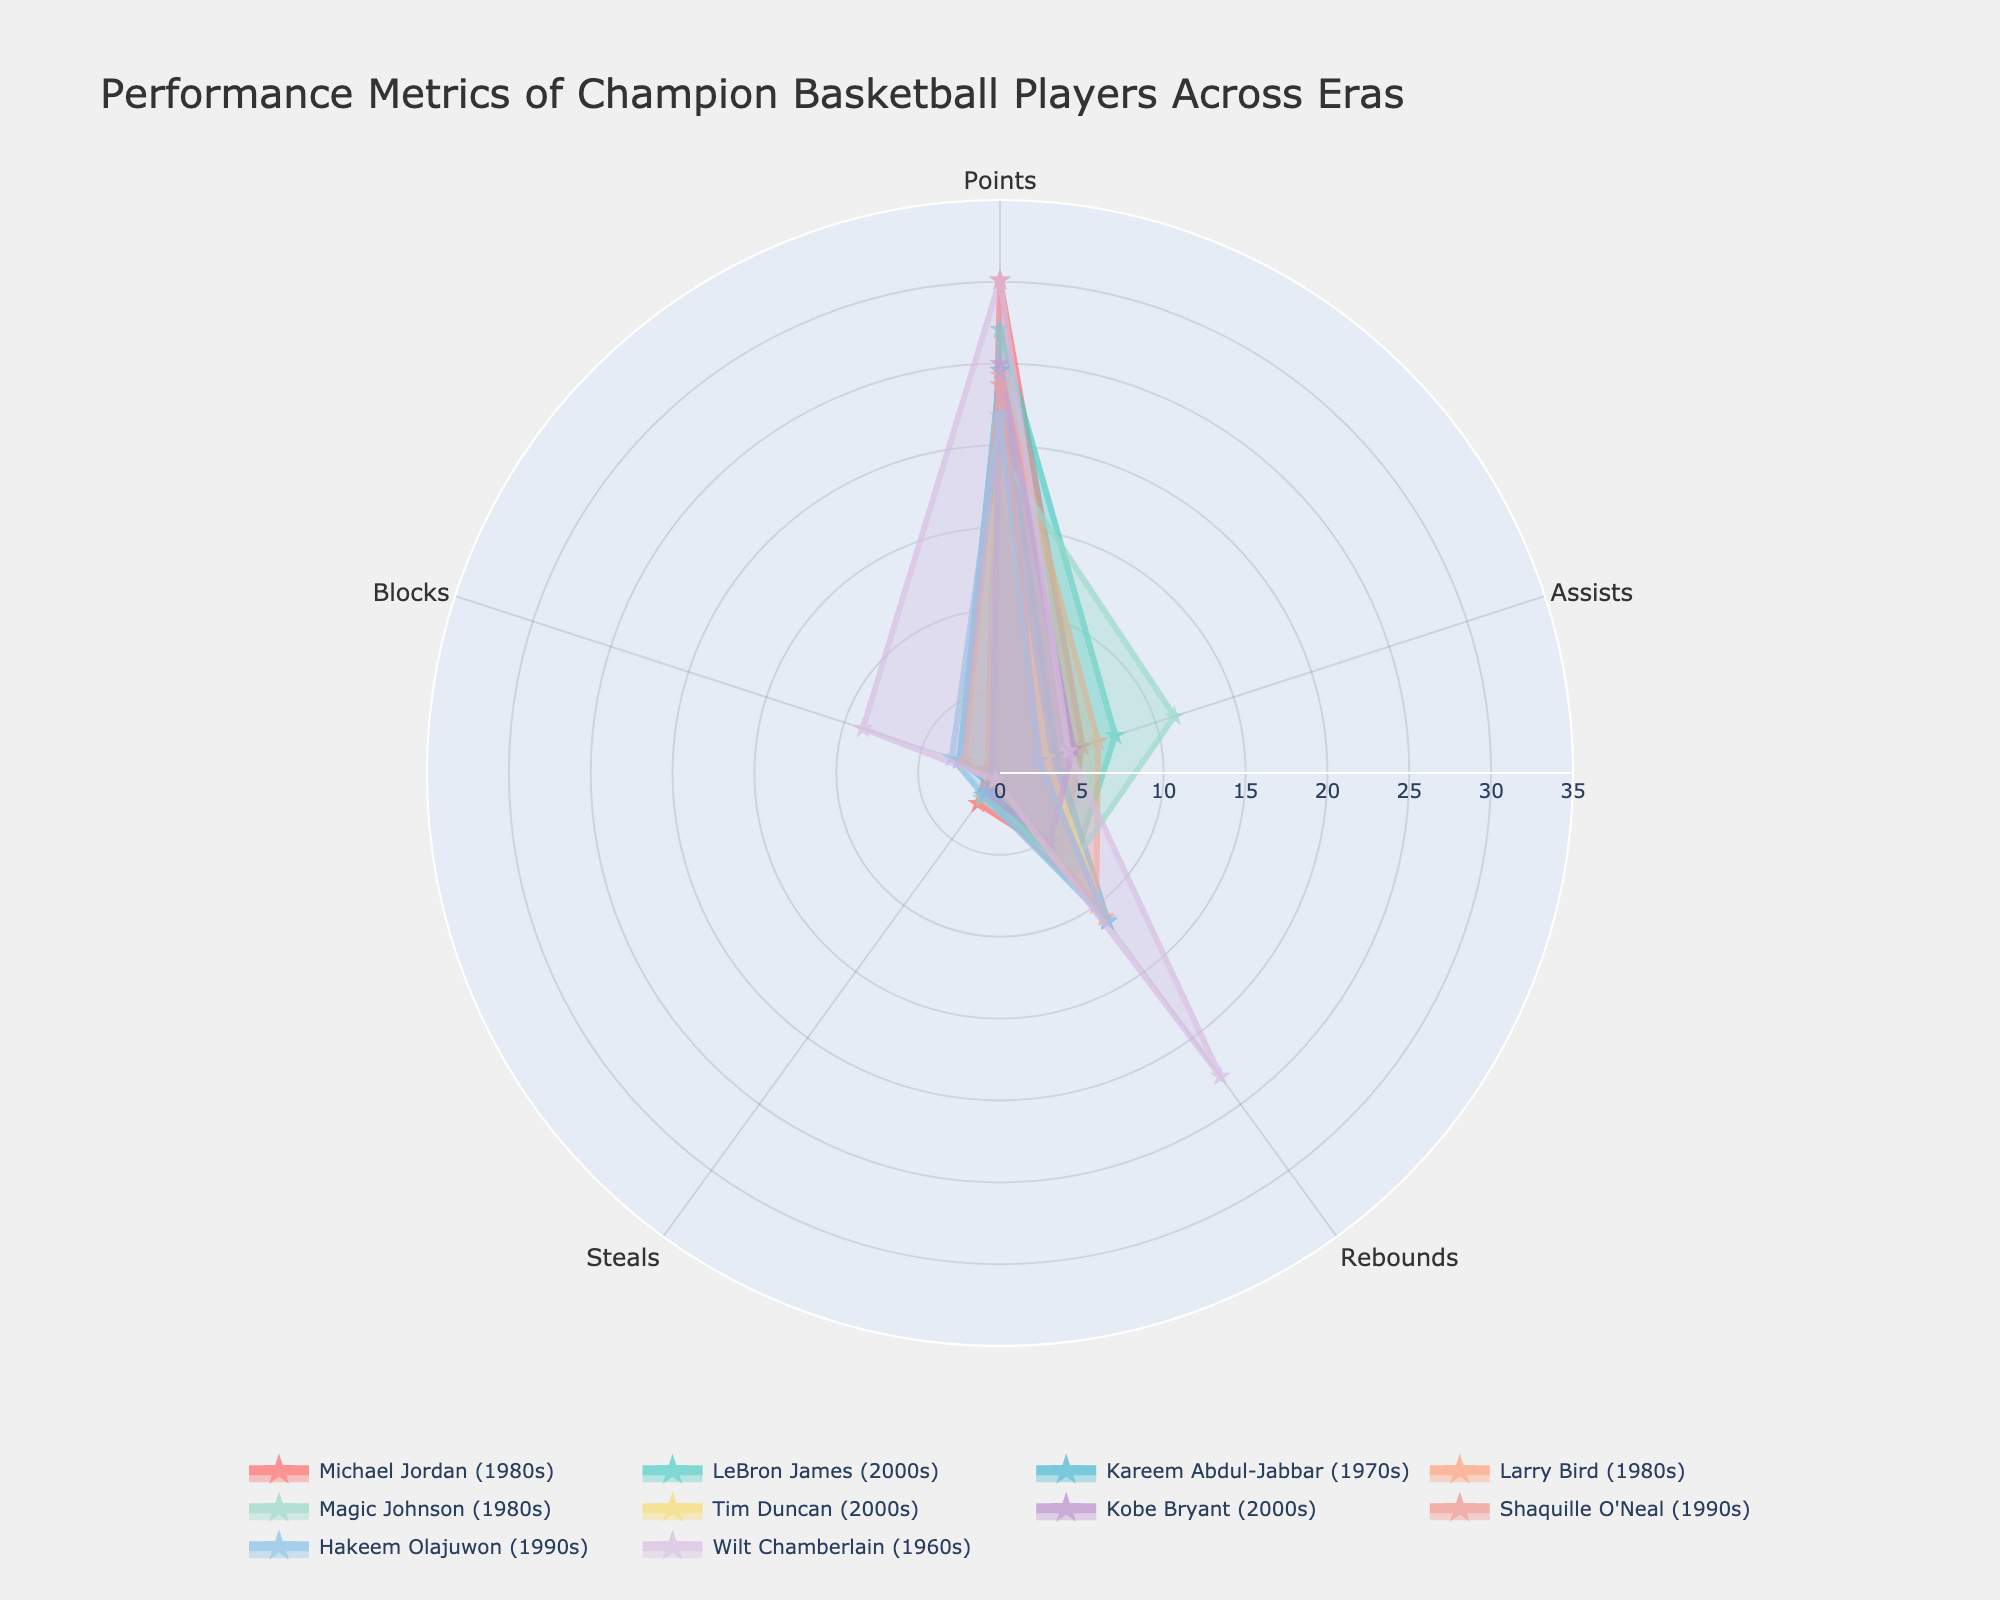how many players' performance metrics are compared in this radar chart? To find out how many players are compared, you should count the number of unique traces on the radar chart. Each trace represents a player's performance metrics.
Answer: 10 Which player has the highest blocks stat in the chart? To determine which player has the highest blocks, look for the trace that reaches the highest value on the blocks axis of the radar chart.
Answer: Wilt Chamberlain Who has higher assists, Larry Bird or Magic Johnson? Compare the positions of Larry Bird's and Magic Johnson's traces on the assists axis. Larry Bird's value for assists is lower than Magic Johnson's.
Answer: Magic Johnson Which era's players dominate the points stat the most? Review which players from specific eras have high values on the points axis. Michael Jordan (1980s) and Wilt Chamberlain (1960s) are both tied with the highest point values, so the dominance is shared across their eras.
Answer: 1980s and 1960s Calculate the average points scored by the players in the 2000s era. First, identify the players from the 2000s (LeBron James, Tim Duncan, and Kobe Bryant). Then, sum their points values (27.1 + 19 + 25) and divide by the number of players (3).
Answer: 23.7 Between Shaquille O'Neal and Hakeem Olajuwon, who has better overall defensive stats in terms of steals and blocks? For defensive stats, add the steals and blocks values for both Shaquille O'Neal (0.6 + 2.3 = 2.9) and Hakeem Olajuwon (1.7 + 3.1 = 4.8). Hakeem Olajuwon's total is higher.
Answer: Hakeem Olajuwon Compare the rebounds of Kareem Abdul-Jabbar and Tim Duncan. Who has more? Look at the rebounds axis for Kareem Abdul-Jabbar and Tim Duncan. Abdul-Jabbar's value is 11.2, higher than Duncan's 10.8.
Answer: Kareem Abdul-Jabbar Based on the radar chart, who is more balanced in terms of performance metrics, LeBron James or Michael Jordan? Evaluate the traces for both players across all performance metrics. LeBron James shows more consistency across all metrics (all values are relatively similar), whereas Michael Jordan has a higher variation with extreme strengths and weaknesses.
Answer: LeBron James 